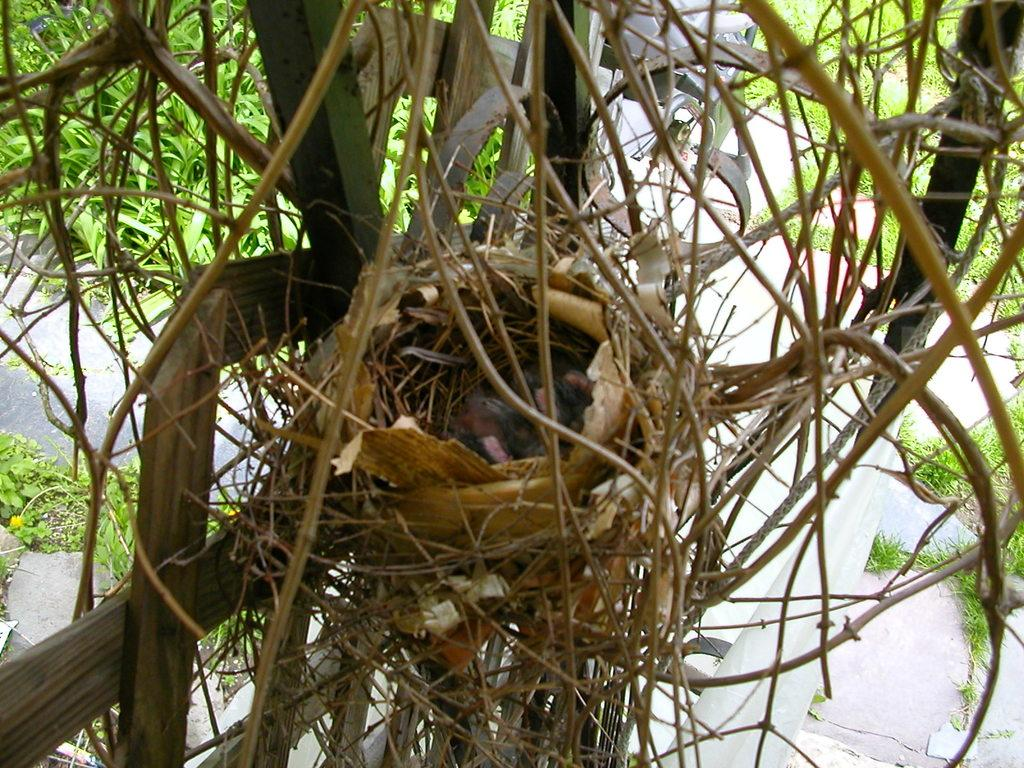What is the main subject in the center of the image? There is a nest in the center of the image. What type of material is used to create the nest? The nest is made of dried grass, which can be seen in the image. What can be seen in the background of the image? There are trees in the background of the image. What type of popcorn is being served in the nest? There is no popcorn present in the image; it features a nest made of dried grass. What name is given to the bird that built the nest in the image? The image does not provide information about the bird that built the nest, so we cannot determine its name. 